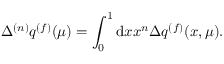<formula> <loc_0><loc_0><loc_500><loc_500>\Delta ^ { ( n ) } q ^ { ( f ) } ( \mu ) = \int _ { 0 } ^ { 1 } d x x ^ { n } \Delta q ^ { ( f ) } ( x , \mu ) .</formula> 